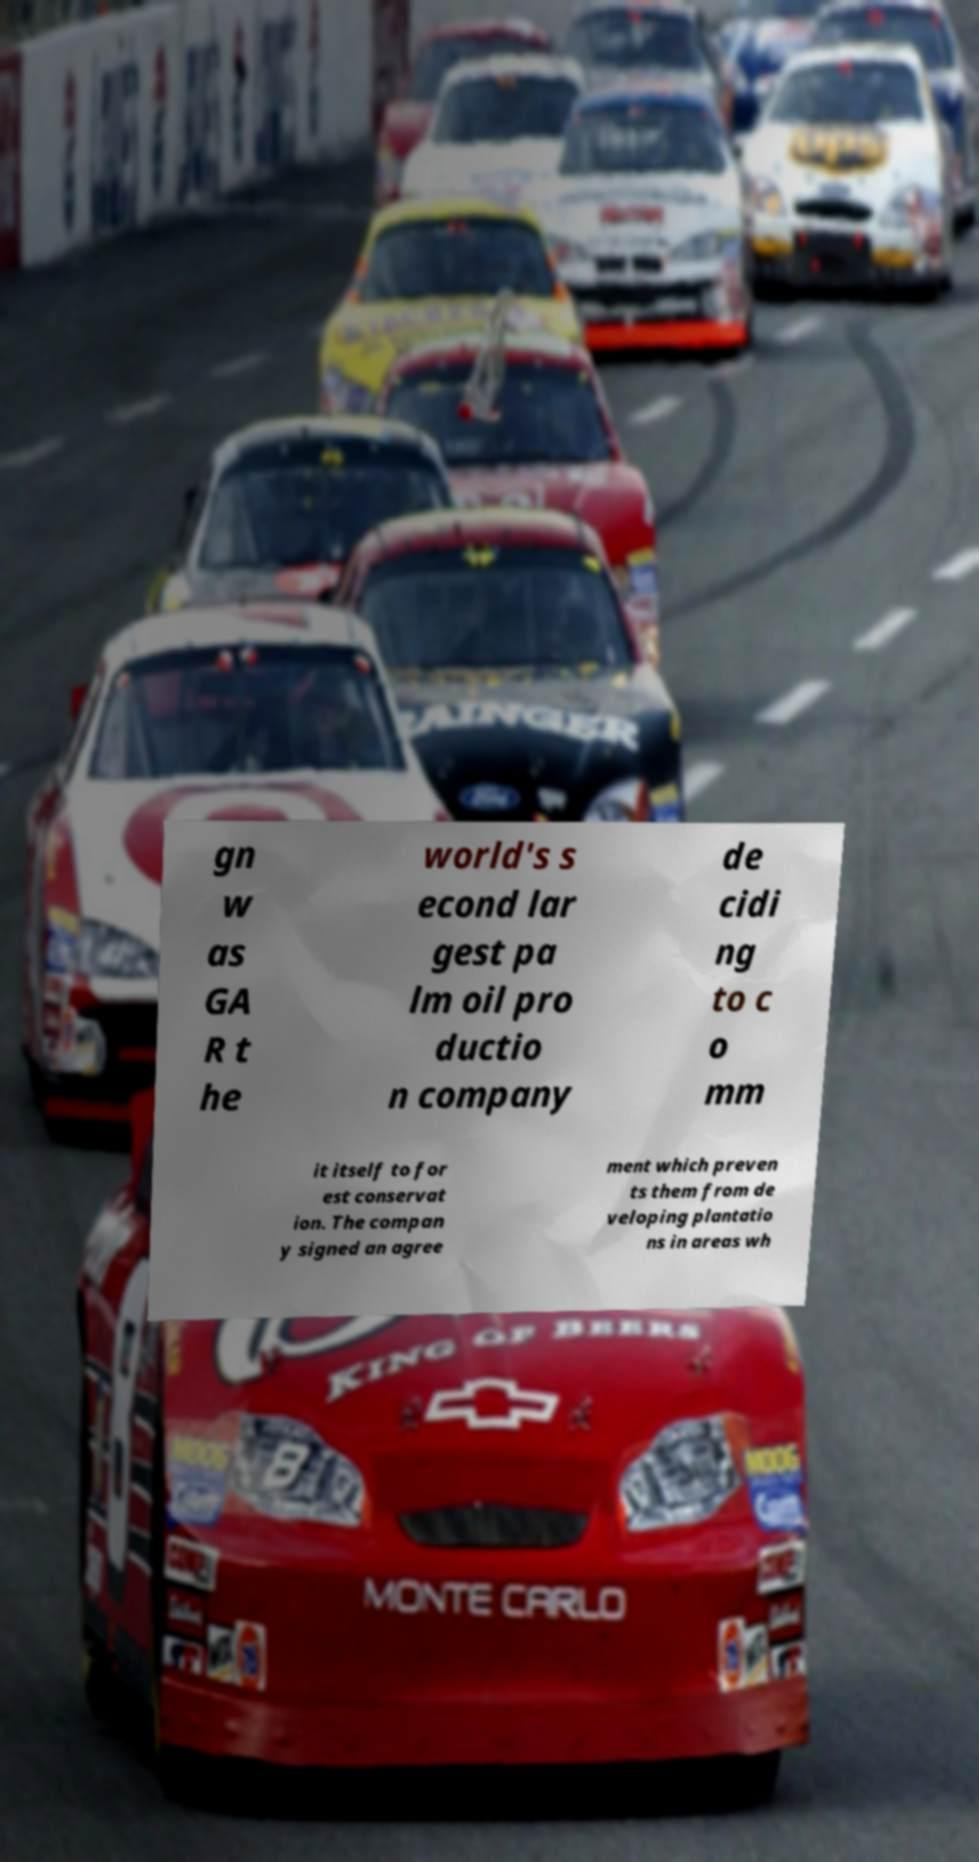Please read and relay the text visible in this image. What does it say? gn w as GA R t he world's s econd lar gest pa lm oil pro ductio n company de cidi ng to c o mm it itself to for est conservat ion. The compan y signed an agree ment which preven ts them from de veloping plantatio ns in areas wh 